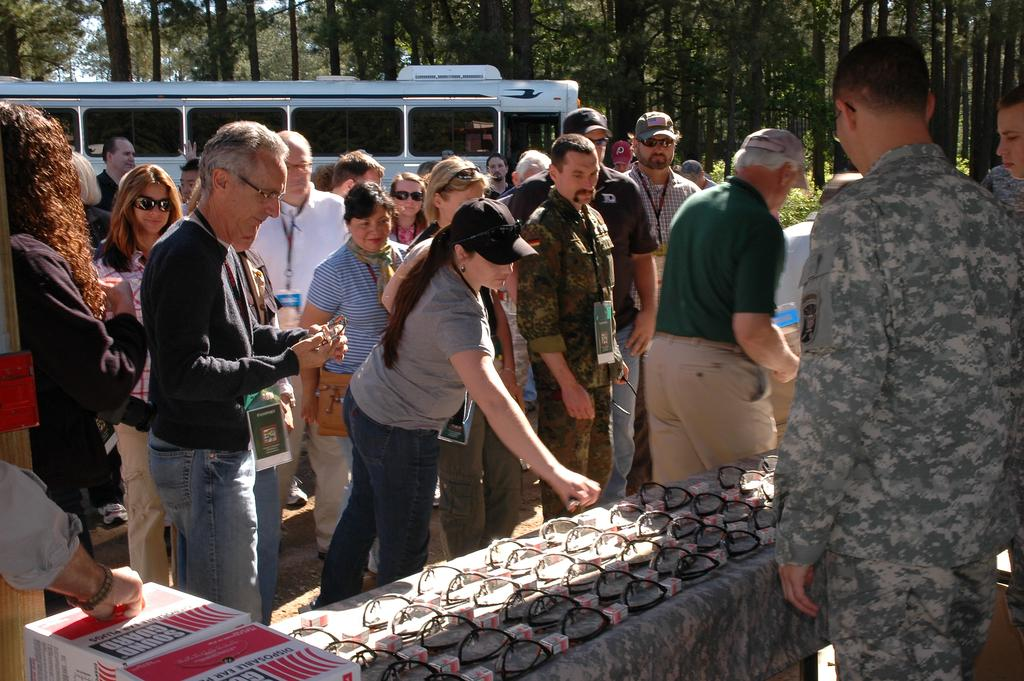What can be seen in the image? There are people standing in the image, along with carton boxes and goggles on a table. Where are the persons located in the image? There are persons on the right side of the image. What is visible in the background of the image? There is a vehicle, trees, and the sky visible in the background of the image. Can you tell me how many bones are on the tray in the image? There is no tray or bones present in the image. How many steps are visible in the image? There is no reference to steps in the image. 